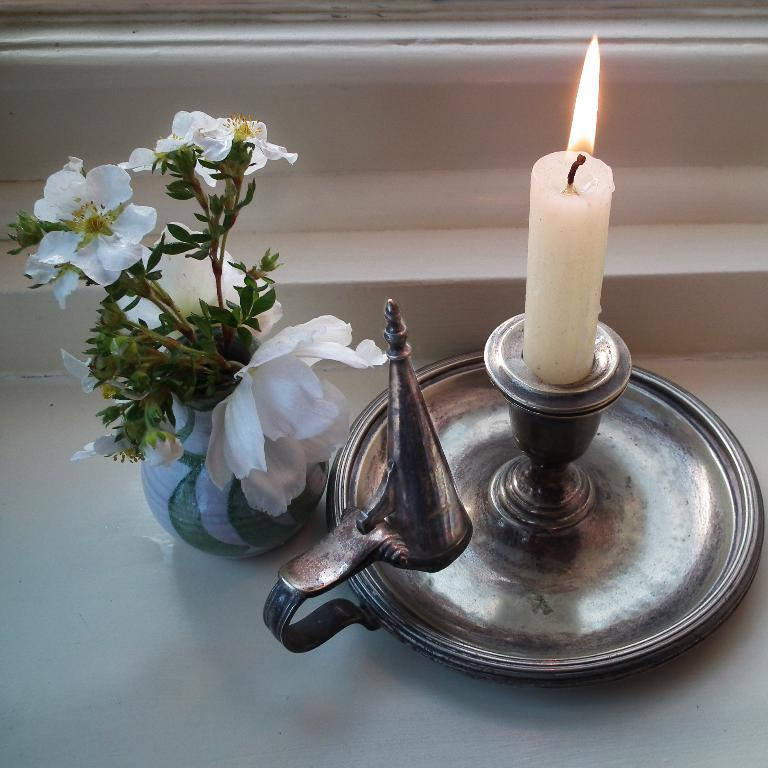What is the main object in the image? There is a candle stand in the image. What is on top of the candle stand? There is a white-colored candle on the candle stand. What other objects can be seen in the image? There are white-colored flowers in a pot in the image. How many rings are on the duck's neck in the image? There is no duck present in the image, and therefore no rings on its neck. 